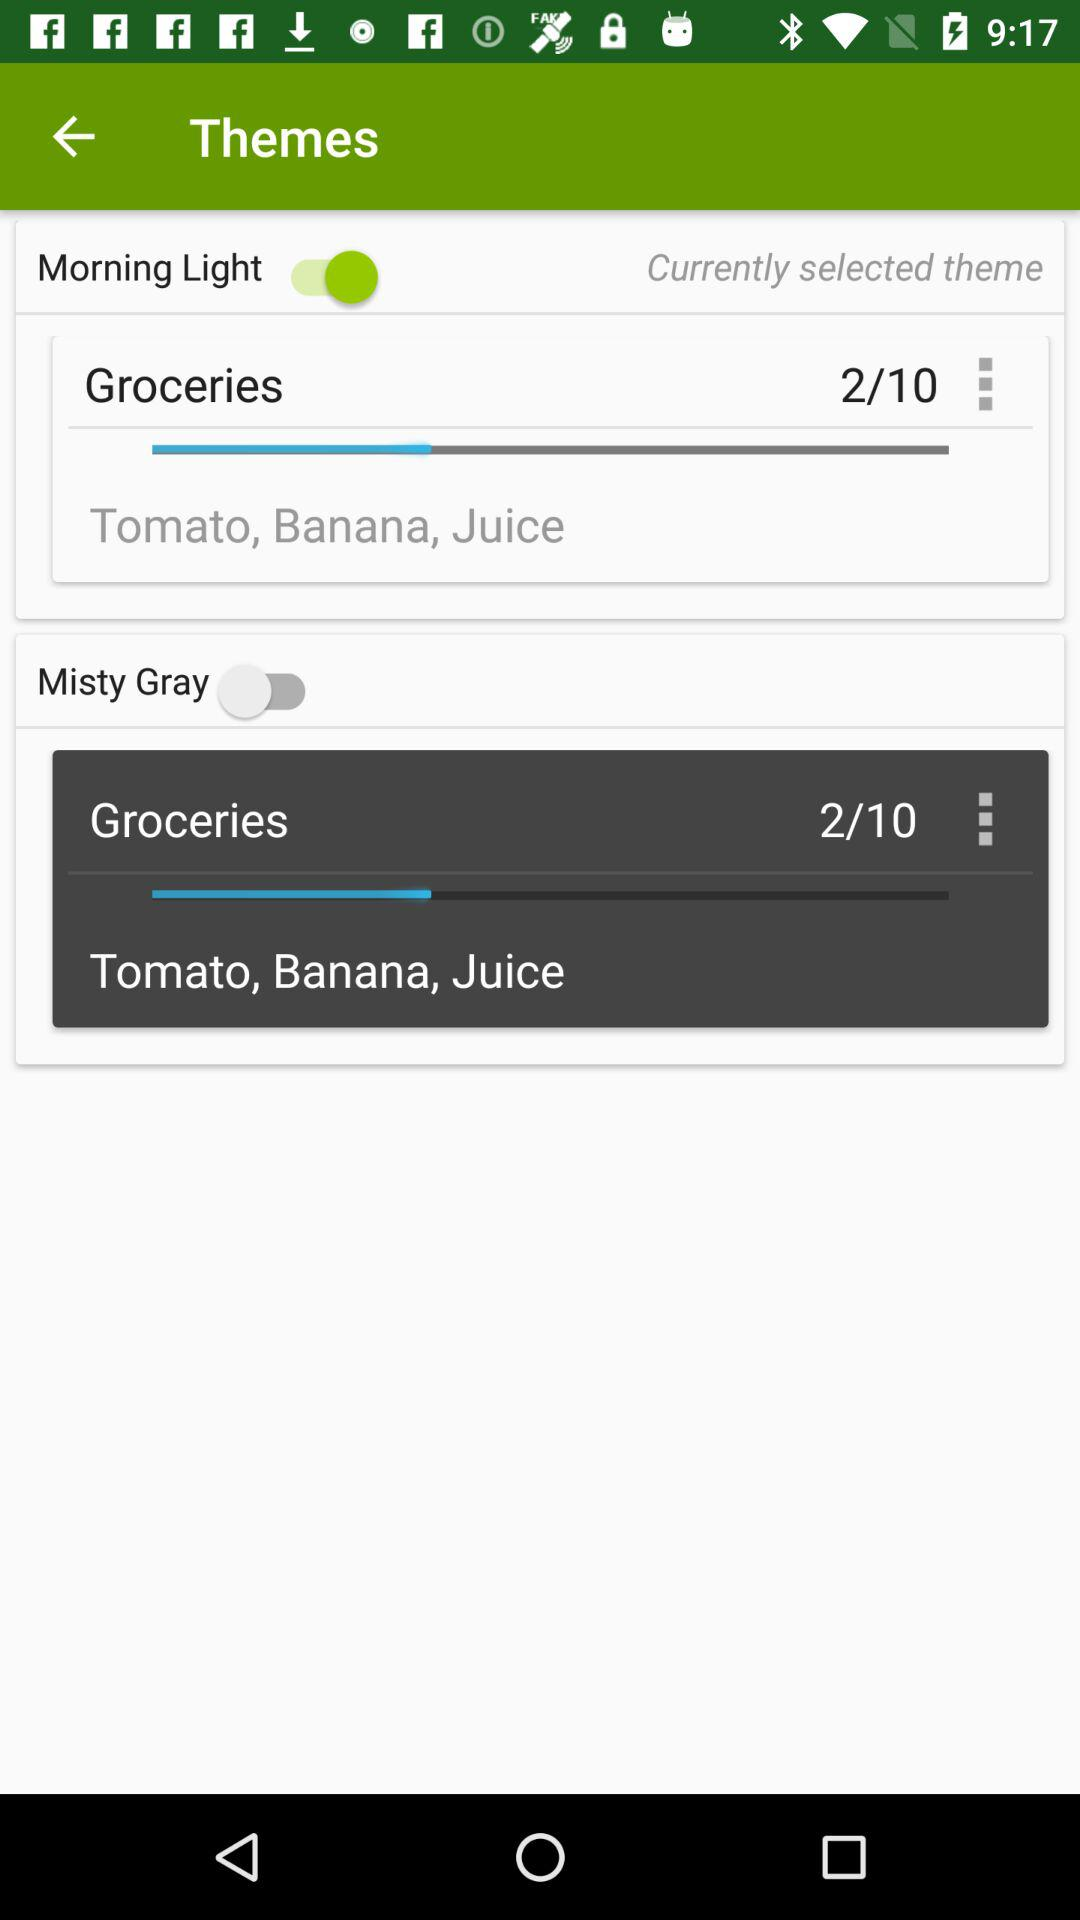What is the current state of "Misty Gray"? The current state is "off". 